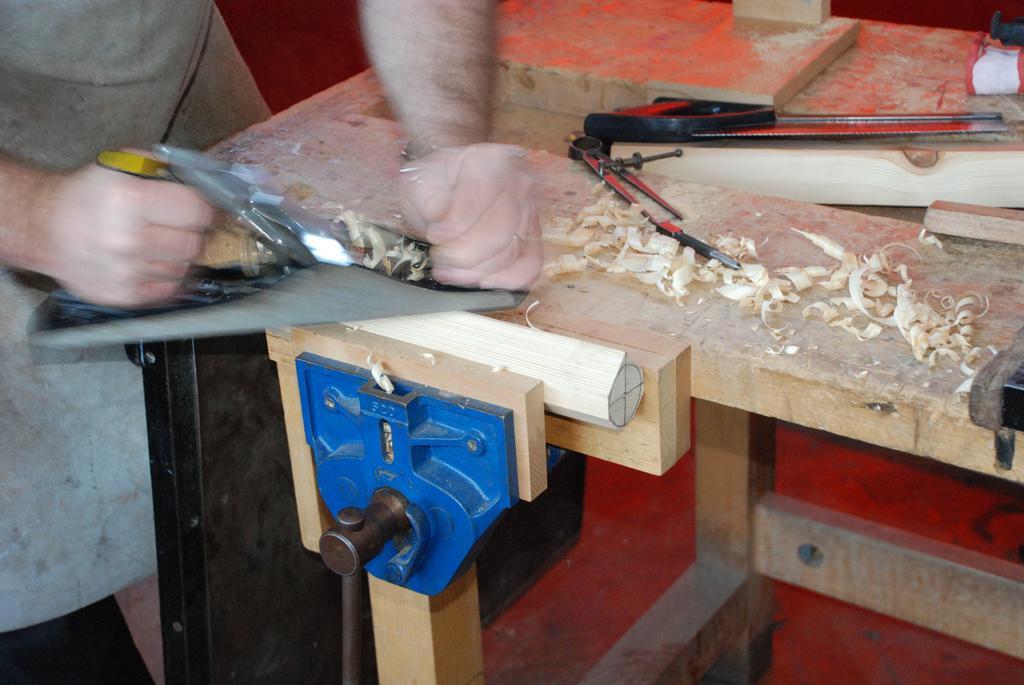Can you describe this image briefly? In this image we can see a man standing and holding a saw. At the bottom there is wood and a table. We can see a saw and a blade placed on the table. 